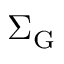Convert formula to latex. <formula><loc_0><loc_0><loc_500><loc_500>\Sigma _ { G }</formula> 